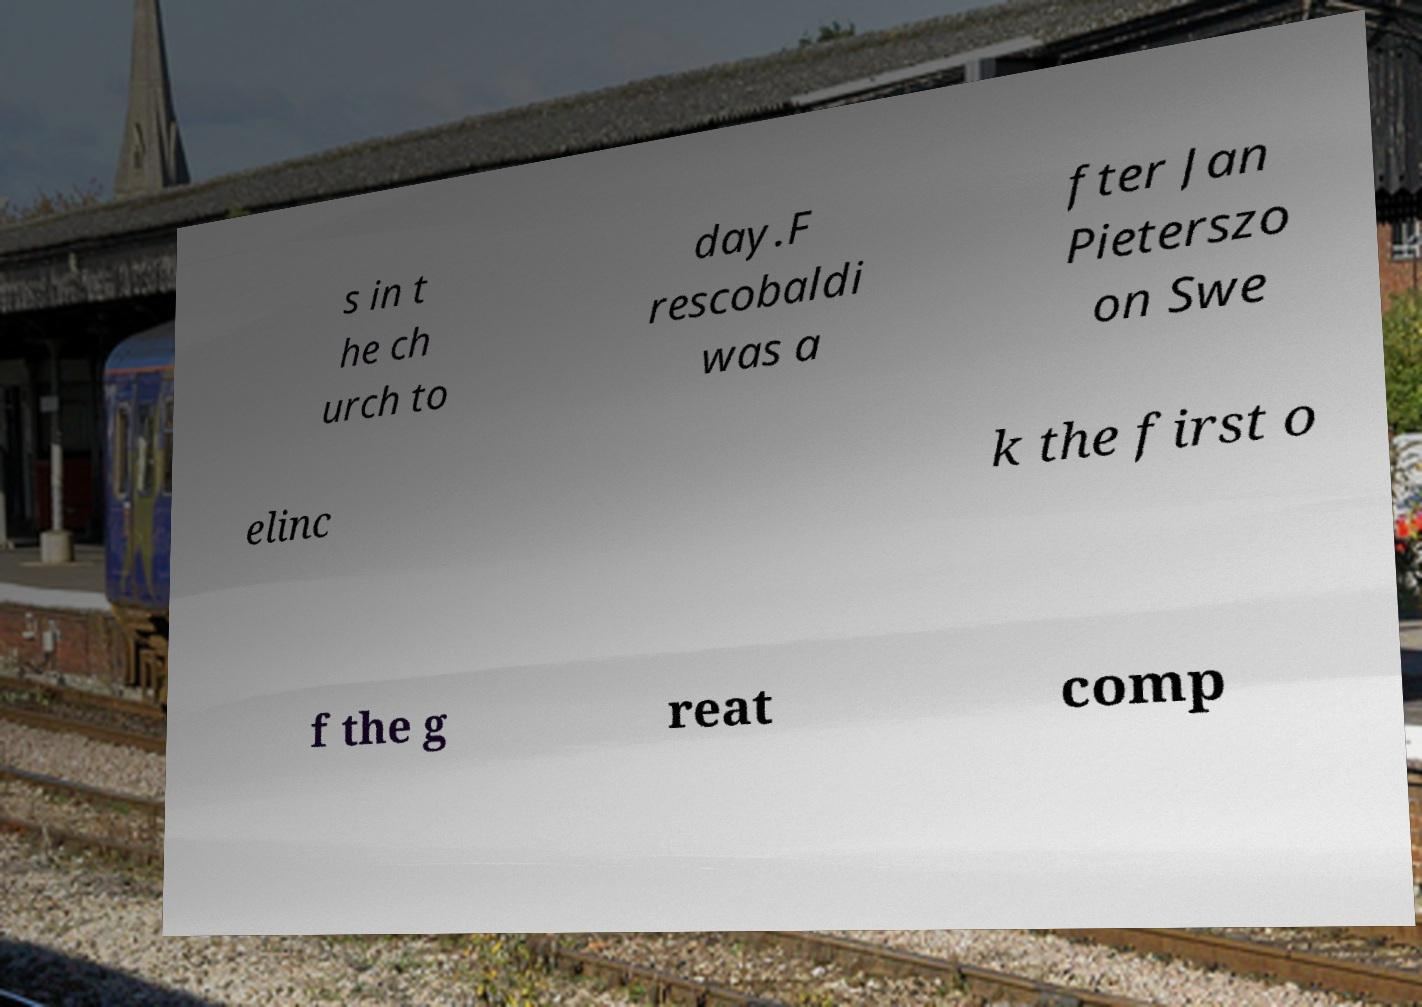Can you accurately transcribe the text from the provided image for me? s in t he ch urch to day.F rescobaldi was a fter Jan Pieterszo on Swe elinc k the first o f the g reat comp 